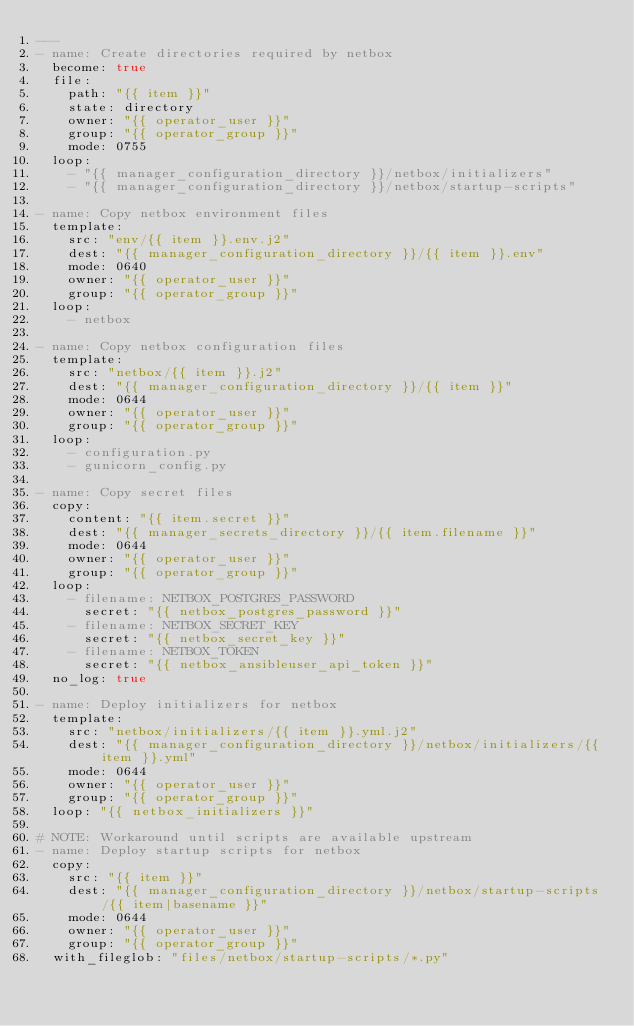<code> <loc_0><loc_0><loc_500><loc_500><_YAML_>---
- name: Create directories required by netbox
  become: true
  file:
    path: "{{ item }}"
    state: directory
    owner: "{{ operator_user }}"
    group: "{{ operator_group }}"
    mode: 0755
  loop:
    - "{{ manager_configuration_directory }}/netbox/initializers"
    - "{{ manager_configuration_directory }}/netbox/startup-scripts"

- name: Copy netbox environment files
  template:
    src: "env/{{ item }}.env.j2"
    dest: "{{ manager_configuration_directory }}/{{ item }}.env"
    mode: 0640
    owner: "{{ operator_user }}"
    group: "{{ operator_group }}"
  loop:
    - netbox

- name: Copy netbox configuration files
  template:
    src: "netbox/{{ item }}.j2"
    dest: "{{ manager_configuration_directory }}/{{ item }}"
    mode: 0644
    owner: "{{ operator_user }}"
    group: "{{ operator_group }}"
  loop:
    - configuration.py
    - gunicorn_config.py

- name: Copy secret files
  copy:
    content: "{{ item.secret }}"
    dest: "{{ manager_secrets_directory }}/{{ item.filename }}"
    mode: 0644
    owner: "{{ operator_user }}"
    group: "{{ operator_group }}"
  loop:
    - filename: NETBOX_POSTGRES_PASSWORD
      secret: "{{ netbox_postgres_password }}"
    - filename: NETBOX_SECRET_KEY
      secret: "{{ netbox_secret_key }}"
    - filename: NETBOX_TOKEN
      secret: "{{ netbox_ansibleuser_api_token }}"
  no_log: true

- name: Deploy initializers for netbox
  template:
    src: "netbox/initializers/{{ item }}.yml.j2"
    dest: "{{ manager_configuration_directory }}/netbox/initializers/{{ item }}.yml"
    mode: 0644
    owner: "{{ operator_user }}"
    group: "{{ operator_group }}"
  loop: "{{ netbox_initializers }}"

# NOTE: Workaround until scripts are available upstream
- name: Deploy startup scripts for netbox
  copy:
    src: "{{ item }}"
    dest: "{{ manager_configuration_directory }}/netbox/startup-scripts/{{ item|basename }}"
    mode: 0644
    owner: "{{ operator_user }}"
    group: "{{ operator_group }}"
  with_fileglob: "files/netbox/startup-scripts/*.py"
</code> 